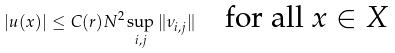Convert formula to latex. <formula><loc_0><loc_0><loc_500><loc_500>| u ( x ) | \leq C ( r ) N ^ { 2 } \sup _ { i , j } \| \nu _ { i , j } \| \quad \text {for all $x\in X$}</formula> 